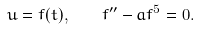<formula> <loc_0><loc_0><loc_500><loc_500>u = f ( t ) , \quad f ^ { \prime \prime } - a f ^ { 5 } = 0 .</formula> 